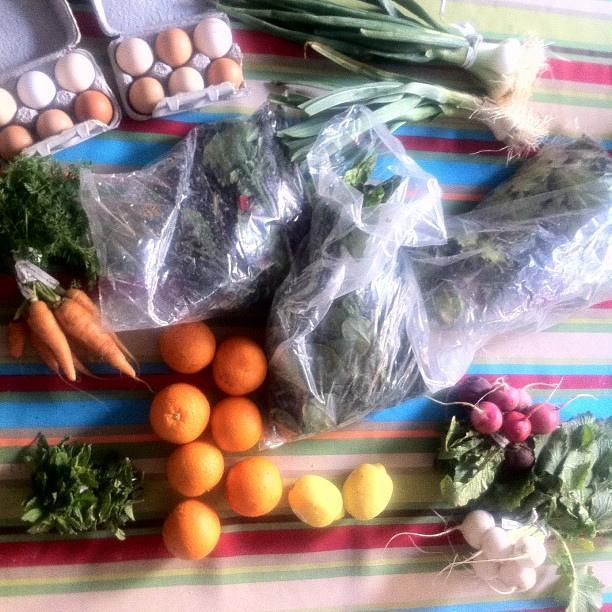How many lemons are there?
Give a very brief answer. 2. How many oranges are there?
Give a very brief answer. 7. How many blue cars are in the picture?
Give a very brief answer. 0. 